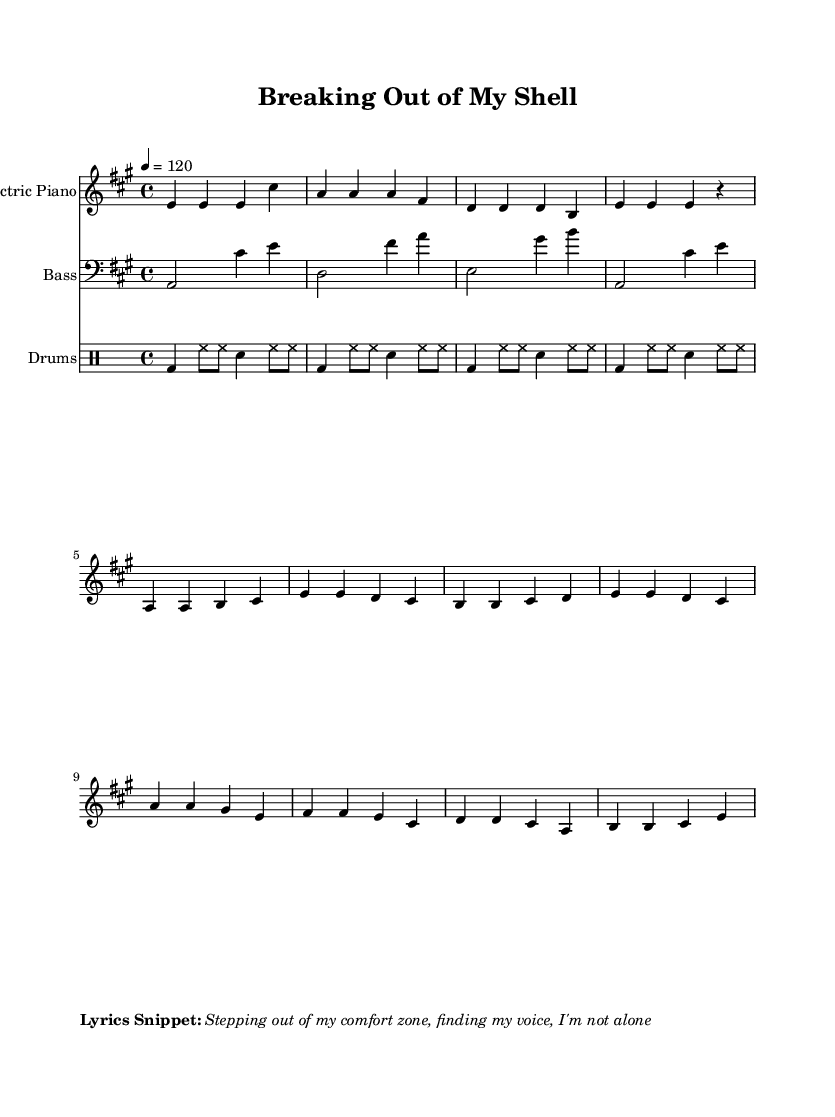What is the key signature of this music? The key signature shows an F-sharp and a C-sharp, indicating that the music is in A major.
Answer: A major What is the time signature of this piece? The time signature is found at the beginning of the score, shown as 4 over 4, meaning there are four beats in each measure.
Answer: 4/4 What is the tempo indicated for this music? The tempo marking indicates 120 beats per minute, noted as "4 = 120" in the score.
Answer: 120 How many measures does the electric piano part have? By counting the individual sets of notes, we can see that the electric piano has a total of 12 measures.
Answer: 12 What is the rhythmic pattern played on the drums? The drum pattern alternates between bass drum, hi-hat, and snare in a consistent repeated sequence, creating an upbeat disco feel.
Answer: Bass, hi-hat, snare What genre does this music represent? The upbeat tempo, along with the instrumentation and rhythmic style, clearly aligns it with disco music, characterized by danceable grooves.
Answer: Disco What instrument plays the bass part? The bass part is indicated with the clef notation, showing it is played by a bass guitar.
Answer: Bass guitar 